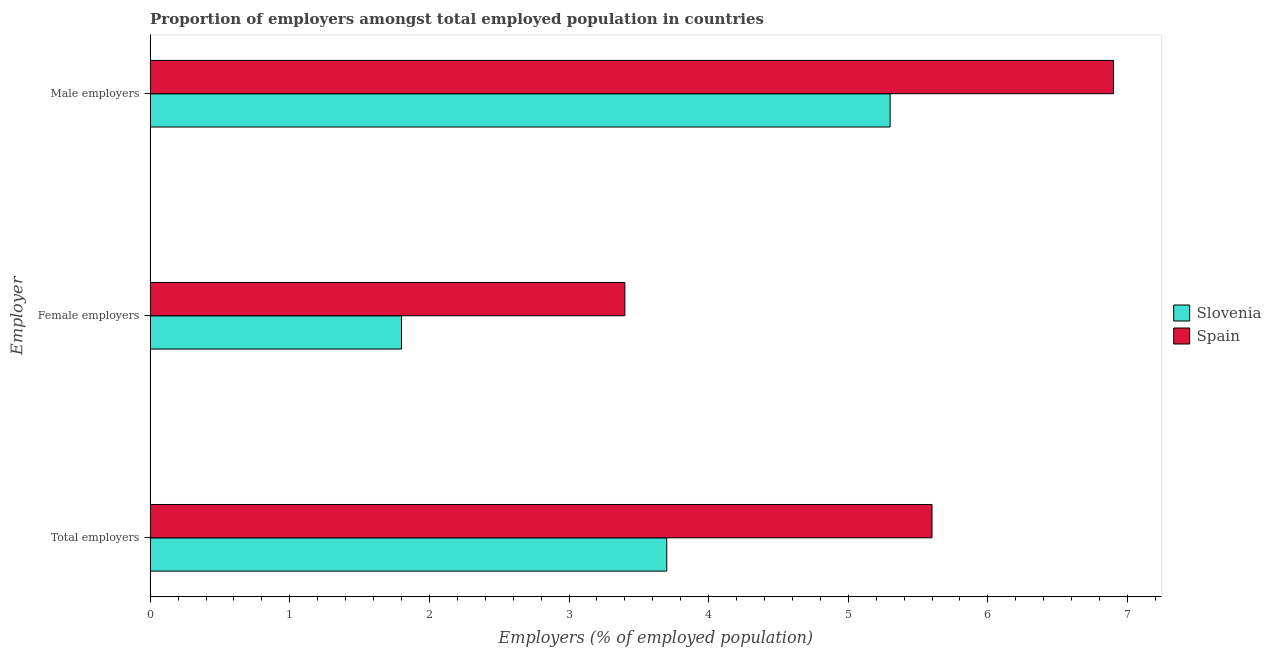How many different coloured bars are there?
Offer a terse response. 2. Are the number of bars on each tick of the Y-axis equal?
Your response must be concise. Yes. How many bars are there on the 3rd tick from the top?
Provide a short and direct response. 2. How many bars are there on the 2nd tick from the bottom?
Keep it short and to the point. 2. What is the label of the 3rd group of bars from the top?
Your answer should be very brief. Total employers. What is the percentage of female employers in Spain?
Your answer should be compact. 3.4. Across all countries, what is the maximum percentage of total employers?
Make the answer very short. 5.6. Across all countries, what is the minimum percentage of female employers?
Your answer should be very brief. 1.8. In which country was the percentage of male employers maximum?
Provide a succinct answer. Spain. In which country was the percentage of female employers minimum?
Provide a succinct answer. Slovenia. What is the total percentage of female employers in the graph?
Give a very brief answer. 5.2. What is the difference between the percentage of male employers in Spain and that in Slovenia?
Offer a terse response. 1.6. What is the difference between the percentage of female employers in Slovenia and the percentage of male employers in Spain?
Offer a terse response. -5.1. What is the average percentage of total employers per country?
Your answer should be compact. 4.65. What is the difference between the percentage of male employers and percentage of total employers in Spain?
Provide a short and direct response. 1.3. In how many countries, is the percentage of male employers greater than 6 %?
Provide a succinct answer. 1. What is the ratio of the percentage of female employers in Spain to that in Slovenia?
Your response must be concise. 1.89. Is the percentage of female employers in Spain less than that in Slovenia?
Offer a very short reply. No. What is the difference between the highest and the second highest percentage of total employers?
Your response must be concise. 1.9. What is the difference between the highest and the lowest percentage of male employers?
Ensure brevity in your answer.  1.6. What does the 1st bar from the bottom in Female employers represents?
Keep it short and to the point. Slovenia. How many bars are there?
Offer a very short reply. 6. What is the difference between two consecutive major ticks on the X-axis?
Offer a very short reply. 1. Are the values on the major ticks of X-axis written in scientific E-notation?
Your answer should be compact. No. Does the graph contain any zero values?
Your answer should be compact. No. How many legend labels are there?
Give a very brief answer. 2. How are the legend labels stacked?
Your response must be concise. Vertical. What is the title of the graph?
Your response must be concise. Proportion of employers amongst total employed population in countries. What is the label or title of the X-axis?
Your response must be concise. Employers (% of employed population). What is the label or title of the Y-axis?
Give a very brief answer. Employer. What is the Employers (% of employed population) of Slovenia in Total employers?
Your answer should be compact. 3.7. What is the Employers (% of employed population) of Spain in Total employers?
Your answer should be compact. 5.6. What is the Employers (% of employed population) of Slovenia in Female employers?
Make the answer very short. 1.8. What is the Employers (% of employed population) of Spain in Female employers?
Your answer should be compact. 3.4. What is the Employers (% of employed population) in Slovenia in Male employers?
Your answer should be very brief. 5.3. What is the Employers (% of employed population) in Spain in Male employers?
Your response must be concise. 6.9. Across all Employer, what is the maximum Employers (% of employed population) of Slovenia?
Provide a succinct answer. 5.3. Across all Employer, what is the maximum Employers (% of employed population) of Spain?
Offer a terse response. 6.9. Across all Employer, what is the minimum Employers (% of employed population) of Slovenia?
Offer a very short reply. 1.8. Across all Employer, what is the minimum Employers (% of employed population) in Spain?
Provide a short and direct response. 3.4. What is the total Employers (% of employed population) of Spain in the graph?
Provide a succinct answer. 15.9. What is the difference between the Employers (% of employed population) of Slovenia in Total employers and that in Female employers?
Your answer should be compact. 1.9. What is the difference between the Employers (% of employed population) of Slovenia in Total employers and that in Male employers?
Your response must be concise. -1.6. What is the difference between the Employers (% of employed population) in Spain in Total employers and that in Male employers?
Make the answer very short. -1.3. What is the difference between the Employers (% of employed population) in Slovenia in Female employers and that in Male employers?
Keep it short and to the point. -3.5. What is the difference between the Employers (% of employed population) of Spain in Female employers and that in Male employers?
Provide a short and direct response. -3.5. What is the difference between the Employers (% of employed population) of Slovenia in Total employers and the Employers (% of employed population) of Spain in Male employers?
Your answer should be very brief. -3.2. What is the average Employers (% of employed population) in Spain per Employer?
Offer a very short reply. 5.3. What is the difference between the Employers (% of employed population) in Slovenia and Employers (% of employed population) in Spain in Total employers?
Give a very brief answer. -1.9. What is the difference between the Employers (% of employed population) of Slovenia and Employers (% of employed population) of Spain in Female employers?
Give a very brief answer. -1.6. What is the ratio of the Employers (% of employed population) in Slovenia in Total employers to that in Female employers?
Offer a terse response. 2.06. What is the ratio of the Employers (% of employed population) of Spain in Total employers to that in Female employers?
Your answer should be compact. 1.65. What is the ratio of the Employers (% of employed population) of Slovenia in Total employers to that in Male employers?
Your answer should be very brief. 0.7. What is the ratio of the Employers (% of employed population) of Spain in Total employers to that in Male employers?
Your answer should be very brief. 0.81. What is the ratio of the Employers (% of employed population) of Slovenia in Female employers to that in Male employers?
Offer a terse response. 0.34. What is the ratio of the Employers (% of employed population) of Spain in Female employers to that in Male employers?
Give a very brief answer. 0.49. What is the difference between the highest and the second highest Employers (% of employed population) of Spain?
Your answer should be very brief. 1.3. What is the difference between the highest and the lowest Employers (% of employed population) of Slovenia?
Provide a short and direct response. 3.5. 